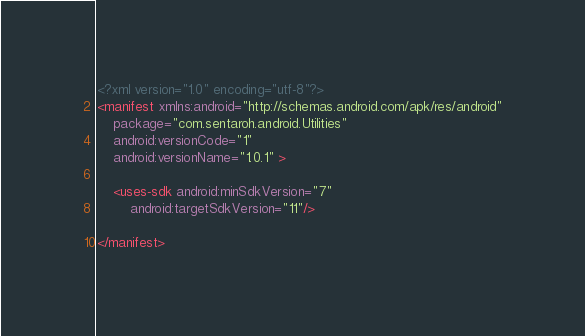<code> <loc_0><loc_0><loc_500><loc_500><_XML_><?xml version="1.0" encoding="utf-8"?>
<manifest xmlns:android="http://schemas.android.com/apk/res/android"
    package="com.sentaroh.android.Utilities"
    android:versionCode="1"
    android:versionName="1.0.1" >

    <uses-sdk android:minSdkVersion="7" 
        android:targetSdkVersion="11"/>

</manifest></code> 